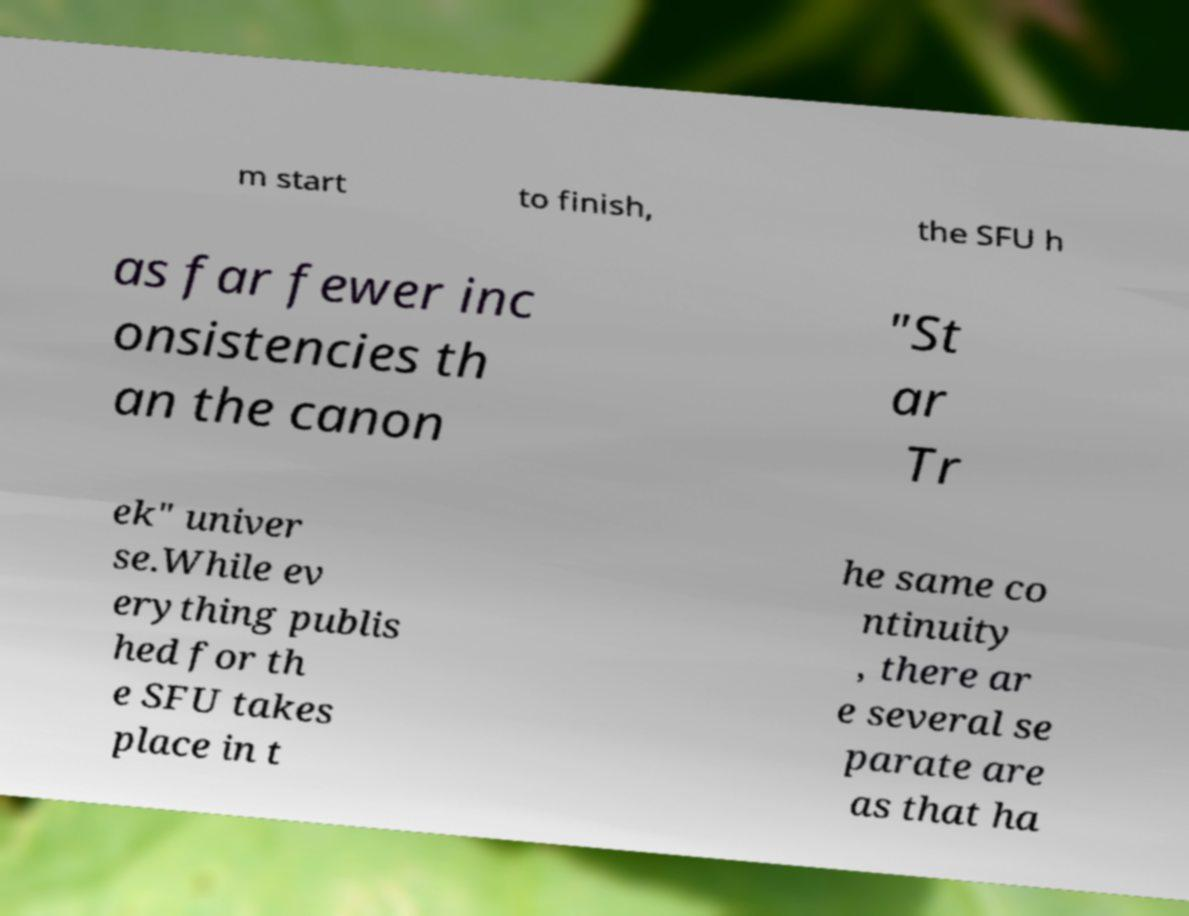Please identify and transcribe the text found in this image. m start to finish, the SFU h as far fewer inc onsistencies th an the canon "St ar Tr ek" univer se.While ev erything publis hed for th e SFU takes place in t he same co ntinuity , there ar e several se parate are as that ha 